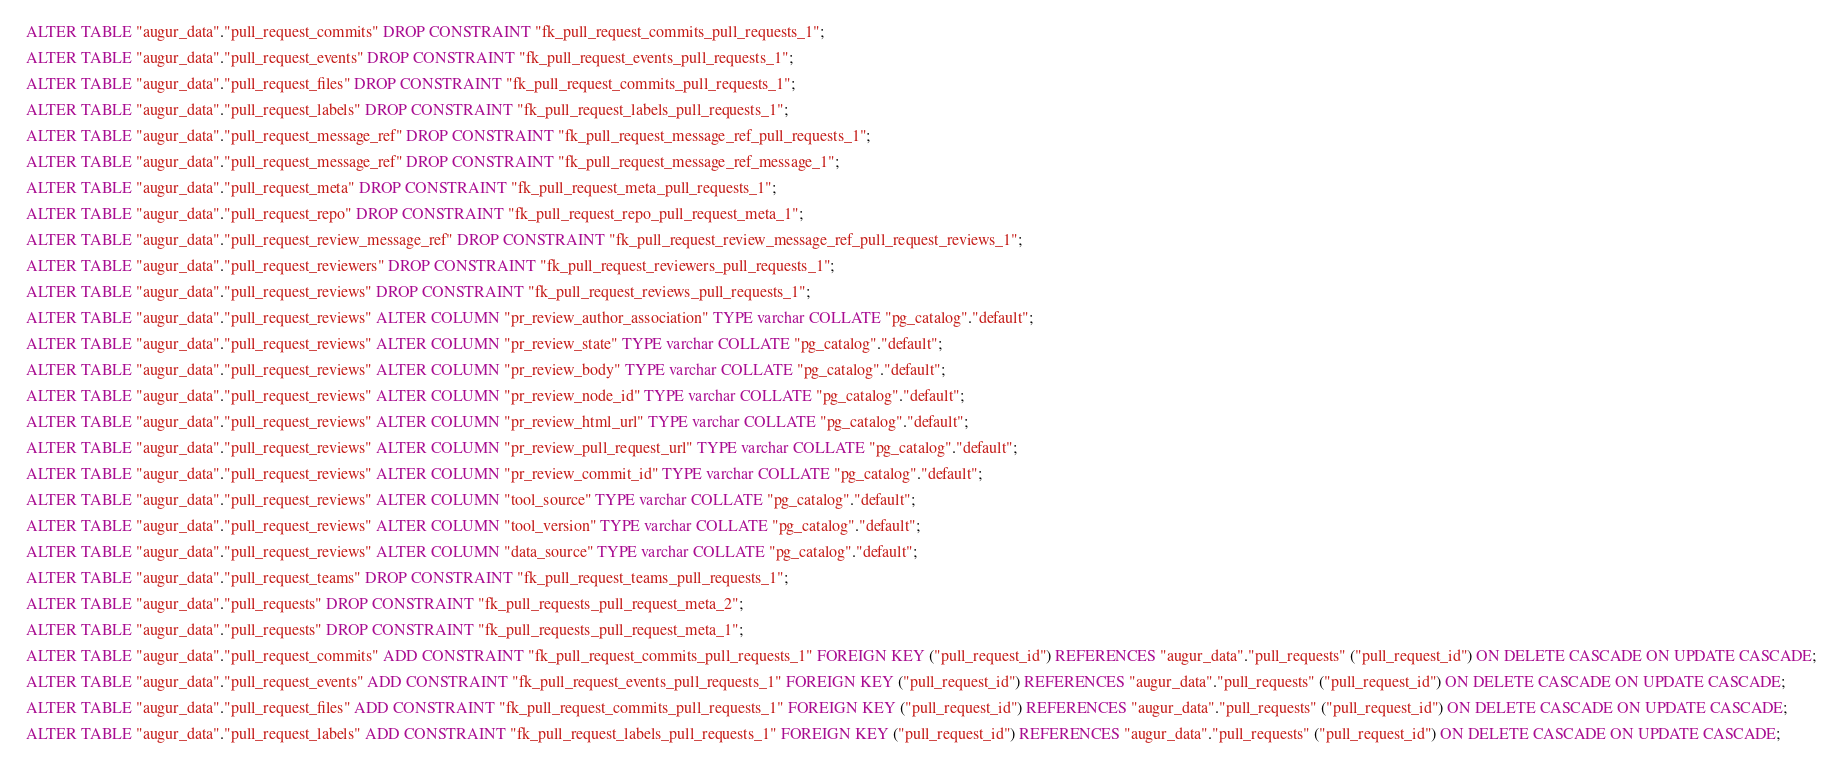Convert code to text. <code><loc_0><loc_0><loc_500><loc_500><_SQL_>ALTER TABLE "augur_data"."pull_request_commits" DROP CONSTRAINT "fk_pull_request_commits_pull_requests_1";

ALTER TABLE "augur_data"."pull_request_events" DROP CONSTRAINT "fk_pull_request_events_pull_requests_1";

ALTER TABLE "augur_data"."pull_request_files" DROP CONSTRAINT "fk_pull_request_commits_pull_requests_1";

ALTER TABLE "augur_data"."pull_request_labels" DROP CONSTRAINT "fk_pull_request_labels_pull_requests_1";

ALTER TABLE "augur_data"."pull_request_message_ref" DROP CONSTRAINT "fk_pull_request_message_ref_pull_requests_1";

ALTER TABLE "augur_data"."pull_request_message_ref" DROP CONSTRAINT "fk_pull_request_message_ref_message_1";

ALTER TABLE "augur_data"."pull_request_meta" DROP CONSTRAINT "fk_pull_request_meta_pull_requests_1";

ALTER TABLE "augur_data"."pull_request_repo" DROP CONSTRAINT "fk_pull_request_repo_pull_request_meta_1";

ALTER TABLE "augur_data"."pull_request_review_message_ref" DROP CONSTRAINT "fk_pull_request_review_message_ref_pull_request_reviews_1";

ALTER TABLE "augur_data"."pull_request_reviewers" DROP CONSTRAINT "fk_pull_request_reviewers_pull_requests_1";

ALTER TABLE "augur_data"."pull_request_reviews" DROP CONSTRAINT "fk_pull_request_reviews_pull_requests_1";

ALTER TABLE "augur_data"."pull_request_reviews" ALTER COLUMN "pr_review_author_association" TYPE varchar COLLATE "pg_catalog"."default";

ALTER TABLE "augur_data"."pull_request_reviews" ALTER COLUMN "pr_review_state" TYPE varchar COLLATE "pg_catalog"."default";

ALTER TABLE "augur_data"."pull_request_reviews" ALTER COLUMN "pr_review_body" TYPE varchar COLLATE "pg_catalog"."default";

ALTER TABLE "augur_data"."pull_request_reviews" ALTER COLUMN "pr_review_node_id" TYPE varchar COLLATE "pg_catalog"."default";

ALTER TABLE "augur_data"."pull_request_reviews" ALTER COLUMN "pr_review_html_url" TYPE varchar COLLATE "pg_catalog"."default";

ALTER TABLE "augur_data"."pull_request_reviews" ALTER COLUMN "pr_review_pull_request_url" TYPE varchar COLLATE "pg_catalog"."default";

ALTER TABLE "augur_data"."pull_request_reviews" ALTER COLUMN "pr_review_commit_id" TYPE varchar COLLATE "pg_catalog"."default";

ALTER TABLE "augur_data"."pull_request_reviews" ALTER COLUMN "tool_source" TYPE varchar COLLATE "pg_catalog"."default";

ALTER TABLE "augur_data"."pull_request_reviews" ALTER COLUMN "tool_version" TYPE varchar COLLATE "pg_catalog"."default";

ALTER TABLE "augur_data"."pull_request_reviews" ALTER COLUMN "data_source" TYPE varchar COLLATE "pg_catalog"."default";

ALTER TABLE "augur_data"."pull_request_teams" DROP CONSTRAINT "fk_pull_request_teams_pull_requests_1";

ALTER TABLE "augur_data"."pull_requests" DROP CONSTRAINT "fk_pull_requests_pull_request_meta_2";

ALTER TABLE "augur_data"."pull_requests" DROP CONSTRAINT "fk_pull_requests_pull_request_meta_1";

ALTER TABLE "augur_data"."pull_request_commits" ADD CONSTRAINT "fk_pull_request_commits_pull_requests_1" FOREIGN KEY ("pull_request_id") REFERENCES "augur_data"."pull_requests" ("pull_request_id") ON DELETE CASCADE ON UPDATE CASCADE;

ALTER TABLE "augur_data"."pull_request_events" ADD CONSTRAINT "fk_pull_request_events_pull_requests_1" FOREIGN KEY ("pull_request_id") REFERENCES "augur_data"."pull_requests" ("pull_request_id") ON DELETE CASCADE ON UPDATE CASCADE;

ALTER TABLE "augur_data"."pull_request_files" ADD CONSTRAINT "fk_pull_request_commits_pull_requests_1" FOREIGN KEY ("pull_request_id") REFERENCES "augur_data"."pull_requests" ("pull_request_id") ON DELETE CASCADE ON UPDATE CASCADE;

ALTER TABLE "augur_data"."pull_request_labels" ADD CONSTRAINT "fk_pull_request_labels_pull_requests_1" FOREIGN KEY ("pull_request_id") REFERENCES "augur_data"."pull_requests" ("pull_request_id") ON DELETE CASCADE ON UPDATE CASCADE;
</code> 